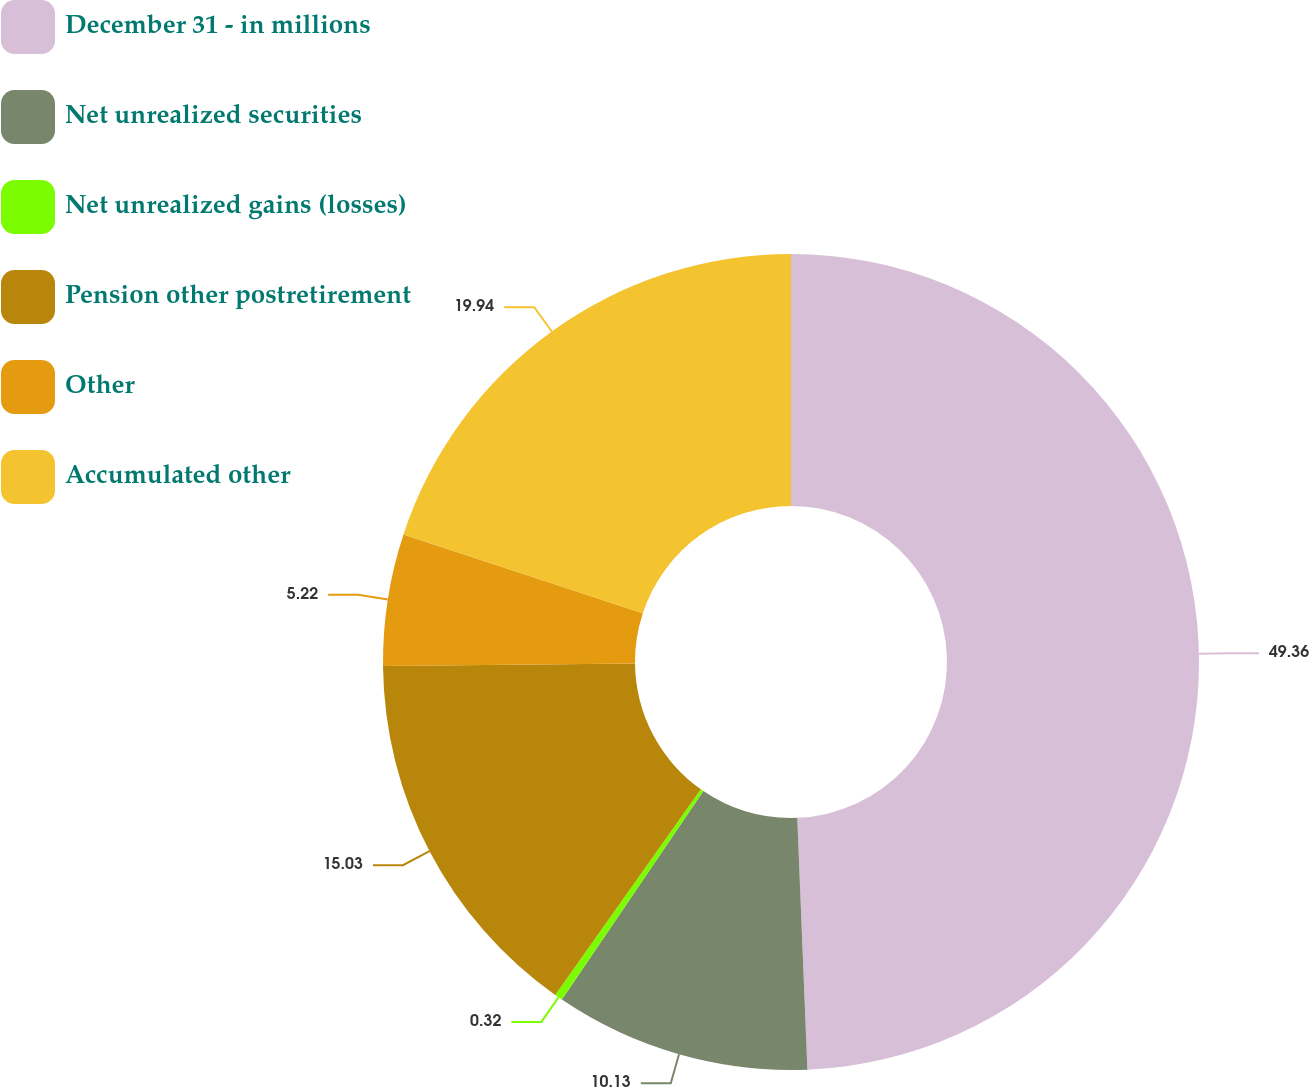<chart> <loc_0><loc_0><loc_500><loc_500><pie_chart><fcel>December 31 - in millions<fcel>Net unrealized securities<fcel>Net unrealized gains (losses)<fcel>Pension other postretirement<fcel>Other<fcel>Accumulated other<nl><fcel>49.36%<fcel>10.13%<fcel>0.32%<fcel>15.03%<fcel>5.22%<fcel>19.94%<nl></chart> 